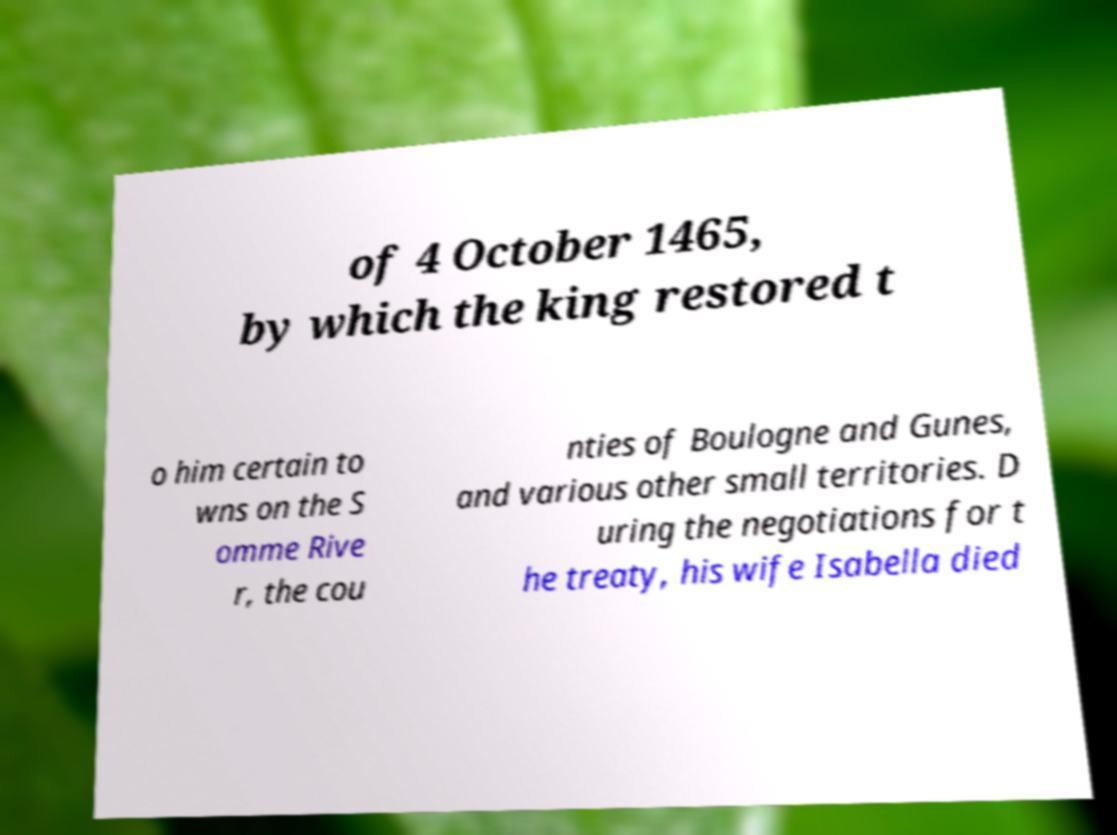Can you accurately transcribe the text from the provided image for me? of 4 October 1465, by which the king restored t o him certain to wns on the S omme Rive r, the cou nties of Boulogne and Gunes, and various other small territories. D uring the negotiations for t he treaty, his wife Isabella died 